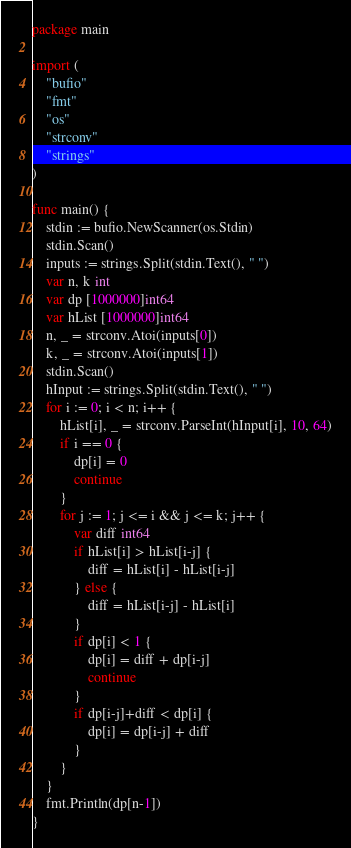Convert code to text. <code><loc_0><loc_0><loc_500><loc_500><_Go_>package main

import (
	"bufio"
	"fmt"
	"os"
	"strconv"
	"strings"
)

func main() {
	stdin := bufio.NewScanner(os.Stdin)
	stdin.Scan()
	inputs := strings.Split(stdin.Text(), " ")
	var n, k int
	var dp [1000000]int64
	var hList [1000000]int64
	n, _ = strconv.Atoi(inputs[0])
	k, _ = strconv.Atoi(inputs[1])
	stdin.Scan()
	hInput := strings.Split(stdin.Text(), " ")
	for i := 0; i < n; i++ {
		hList[i], _ = strconv.ParseInt(hInput[i], 10, 64)
		if i == 0 {
			dp[i] = 0
			continue
		}
		for j := 1; j <= i && j <= k; j++ {
			var diff int64
			if hList[i] > hList[i-j] {
				diff = hList[i] - hList[i-j]
			} else {
				diff = hList[i-j] - hList[i]
			}
			if dp[i] < 1 {
				dp[i] = diff + dp[i-j]
				continue
			}
			if dp[i-j]+diff < dp[i] {
				dp[i] = dp[i-j] + diff
			}
		}
	}
	fmt.Println(dp[n-1])
}
</code> 